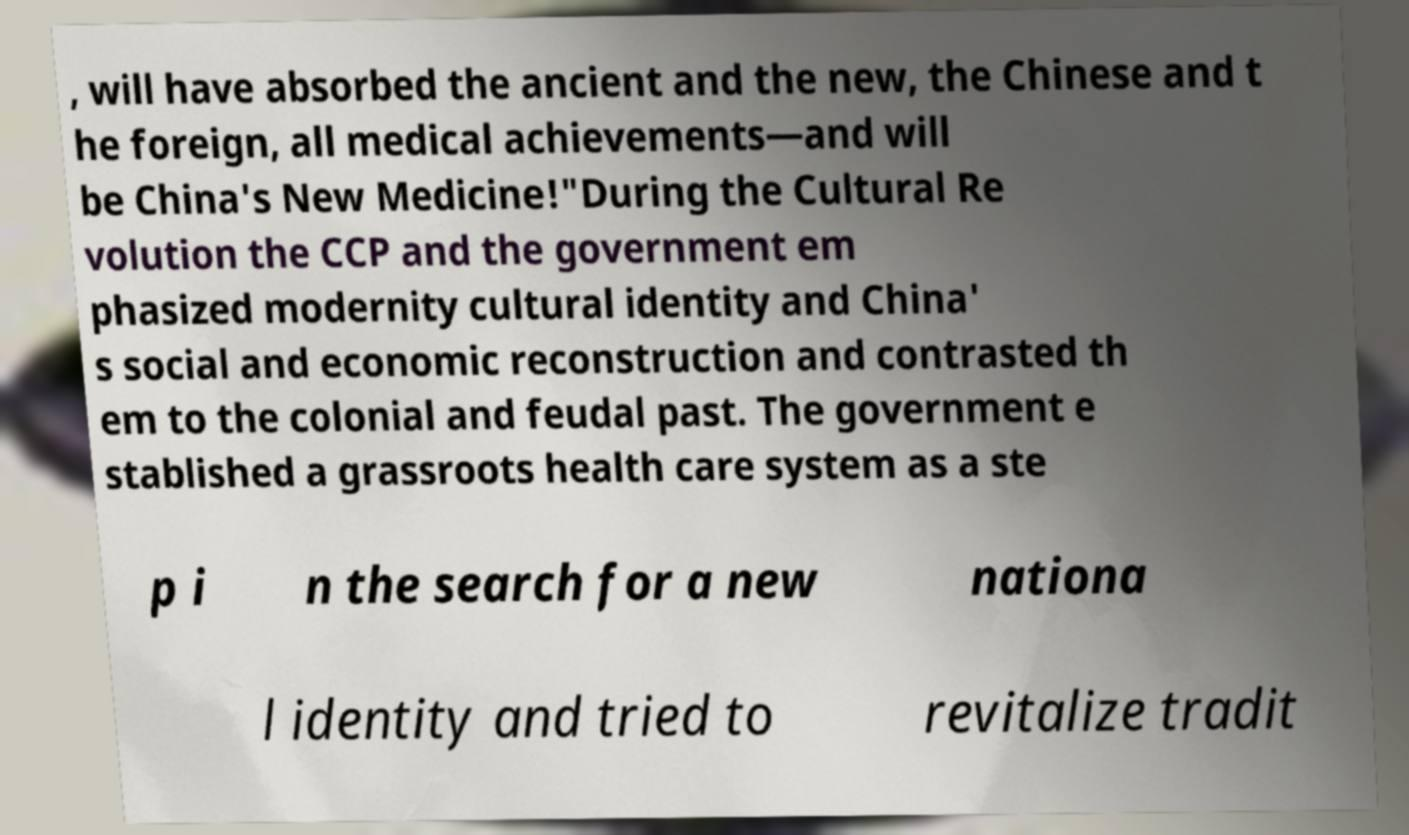There's text embedded in this image that I need extracted. Can you transcribe it verbatim? , will have absorbed the ancient and the new, the Chinese and t he foreign, all medical achievements—and will be China's New Medicine!"During the Cultural Re volution the CCP and the government em phasized modernity cultural identity and China' s social and economic reconstruction and contrasted th em to the colonial and feudal past. The government e stablished a grassroots health care system as a ste p i n the search for a new nationa l identity and tried to revitalize tradit 